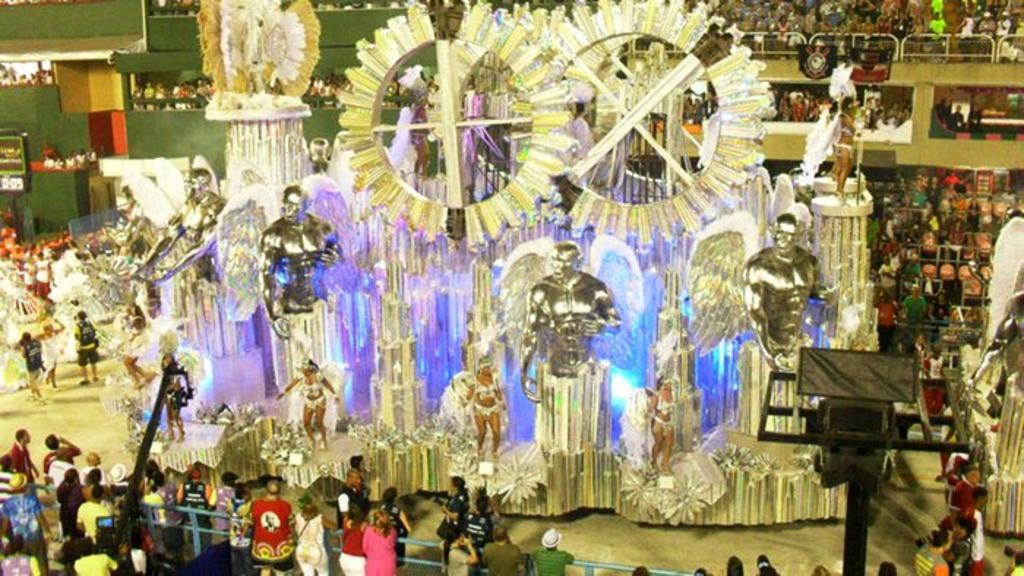What type of structures can be seen in the image? There are human structures in the image. What can be observed in terms of illumination in the image? There are lights visible in the image. What are the men in the middle of the image wearing? The men in the middle of the image are wearing silver-colored dresses. Who else is present in the image besides the men in silver-colored dresses? There are people standing at the bottom of the image, observing the scene. How many balls are being juggled by the men in the image? There is no mention of balls or juggling in the image; the men are wearing silver-colored dresses. What type of shoes are the people wearing at the bottom of the image? There is no information about the shoes worn by the people at the bottom of the image. 